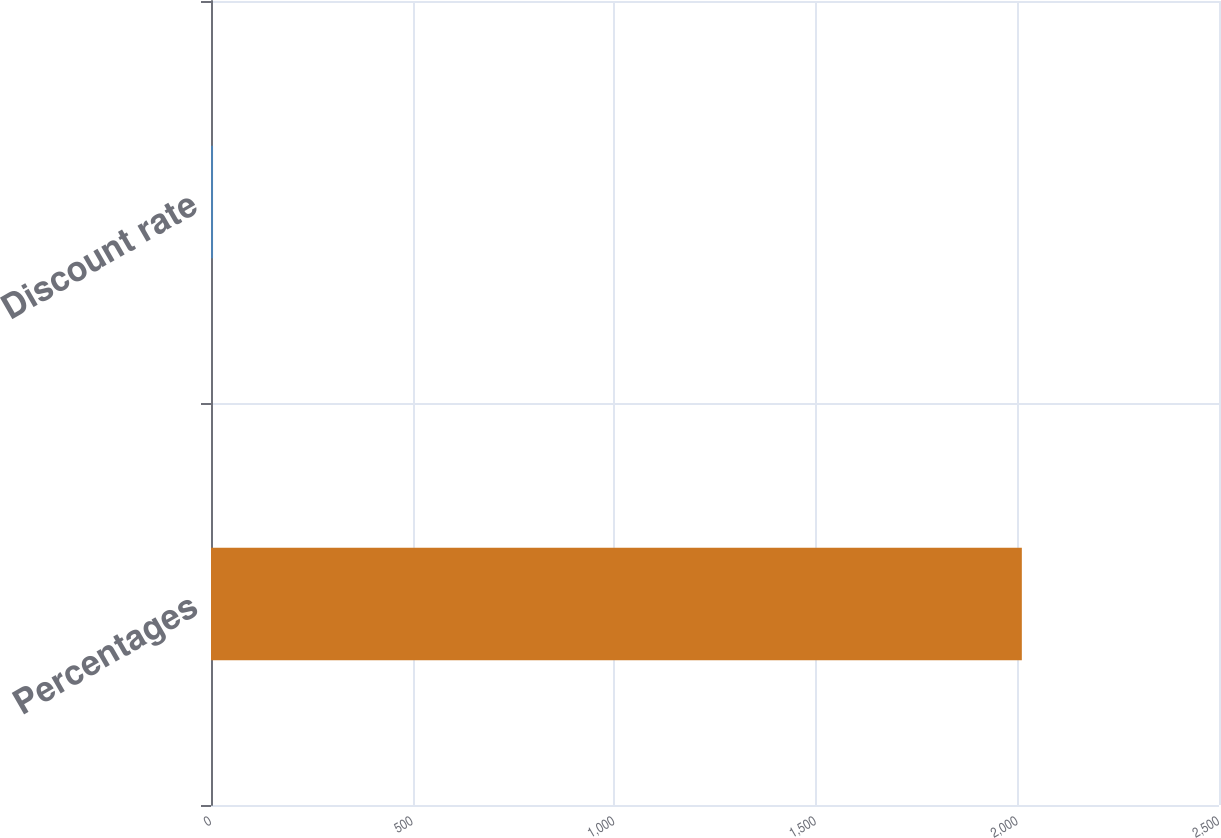<chart> <loc_0><loc_0><loc_500><loc_500><bar_chart><fcel>Percentages<fcel>Discount rate<nl><fcel>2011<fcel>5.05<nl></chart> 